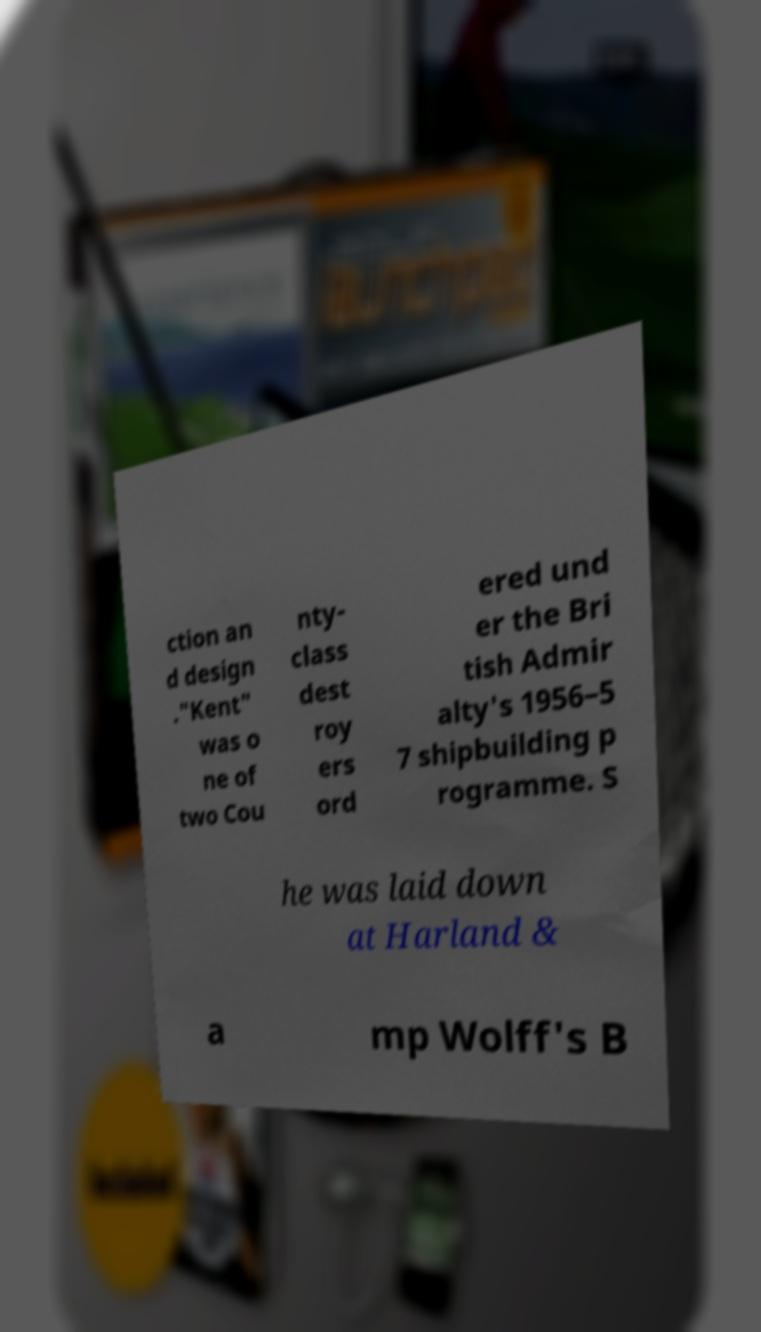Please read and relay the text visible in this image. What does it say? ction an d design ."Kent" was o ne of two Cou nty- class dest roy ers ord ered und er the Bri tish Admir alty's 1956–5 7 shipbuilding p rogramme. S he was laid down at Harland & a mp Wolff's B 